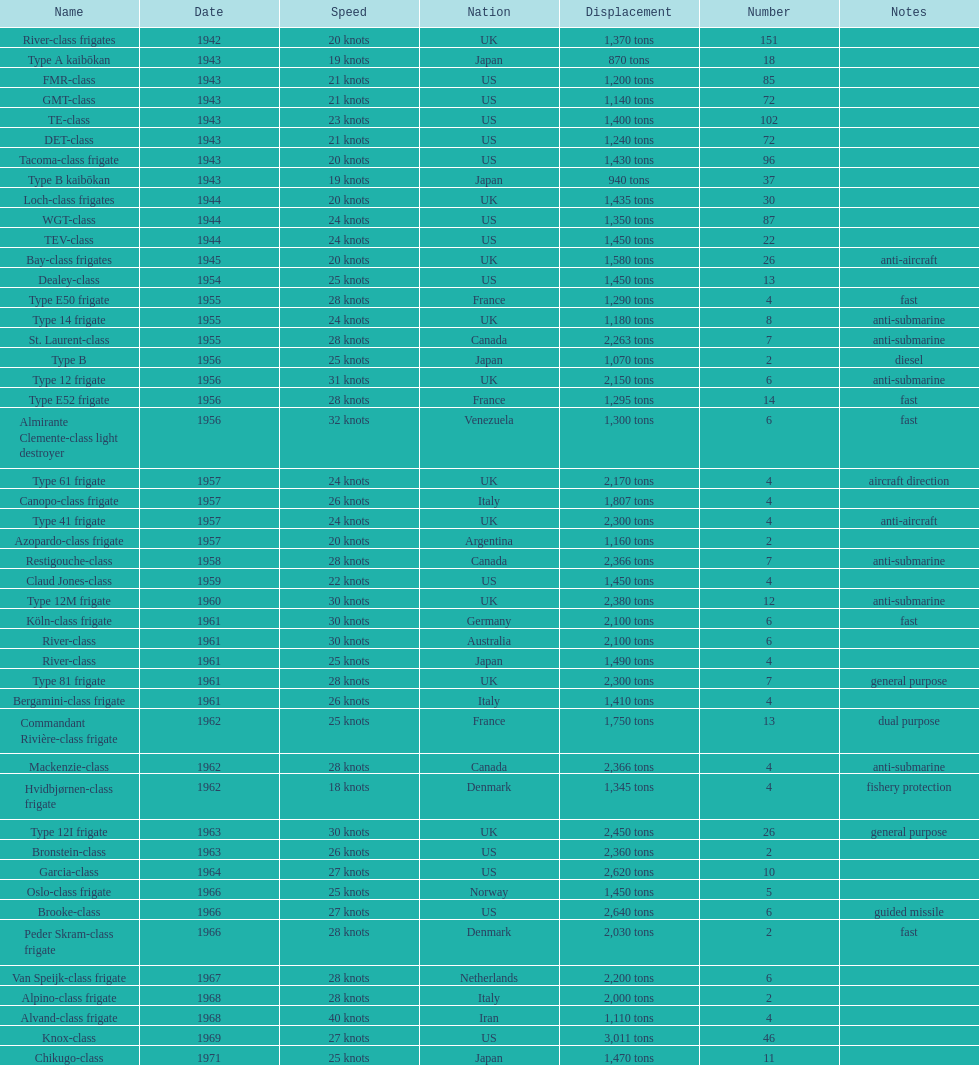In 1968 italy used alpino-class frigate. what was its top speed? 28 knots. 